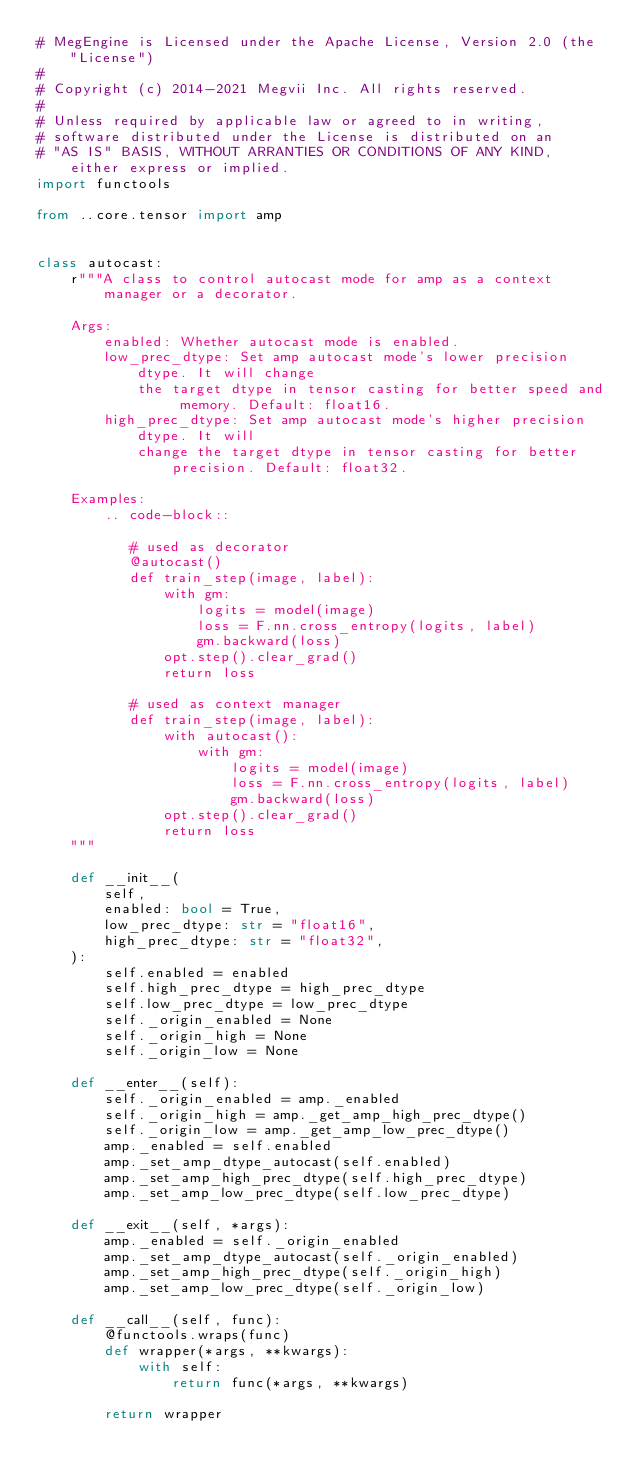<code> <loc_0><loc_0><loc_500><loc_500><_Python_># MegEngine is Licensed under the Apache License, Version 2.0 (the "License")
#
# Copyright (c) 2014-2021 Megvii Inc. All rights reserved.
#
# Unless required by applicable law or agreed to in writing,
# software distributed under the License is distributed on an
# "AS IS" BASIS, WITHOUT ARRANTIES OR CONDITIONS OF ANY KIND, either express or implied.
import functools

from ..core.tensor import amp


class autocast:
    r"""A class to control autocast mode for amp as a context manager or a decorator.

    Args:
        enabled: Whether autocast mode is enabled.
        low_prec_dtype: Set amp autocast mode's lower precision dtype. It will change
            the target dtype in tensor casting for better speed and memory. Default: float16.
        high_prec_dtype: Set amp autocast mode's higher precision dtype. It will
            change the target dtype in tensor casting for better precision. Default: float32.

    Examples:
        .. code-block::

           # used as decorator
           @autocast()
           def train_step(image, label):
               with gm:
                   logits = model(image)
                   loss = F.nn.cross_entropy(logits, label)
                   gm.backward(loss)
               opt.step().clear_grad()
               return loss

           # used as context manager
           def train_step(image, label):
               with autocast():
                   with gm:
                       logits = model(image)
                       loss = F.nn.cross_entropy(logits, label)
                       gm.backward(loss)
               opt.step().clear_grad()
               return loss
    """

    def __init__(
        self,
        enabled: bool = True,
        low_prec_dtype: str = "float16",
        high_prec_dtype: str = "float32",
    ):
        self.enabled = enabled
        self.high_prec_dtype = high_prec_dtype
        self.low_prec_dtype = low_prec_dtype
        self._origin_enabled = None
        self._origin_high = None
        self._origin_low = None

    def __enter__(self):
        self._origin_enabled = amp._enabled
        self._origin_high = amp._get_amp_high_prec_dtype()
        self._origin_low = amp._get_amp_low_prec_dtype()
        amp._enabled = self.enabled
        amp._set_amp_dtype_autocast(self.enabled)
        amp._set_amp_high_prec_dtype(self.high_prec_dtype)
        amp._set_amp_low_prec_dtype(self.low_prec_dtype)

    def __exit__(self, *args):
        amp._enabled = self._origin_enabled
        amp._set_amp_dtype_autocast(self._origin_enabled)
        amp._set_amp_high_prec_dtype(self._origin_high)
        amp._set_amp_low_prec_dtype(self._origin_low)

    def __call__(self, func):
        @functools.wraps(func)
        def wrapper(*args, **kwargs):
            with self:
                return func(*args, **kwargs)

        return wrapper
</code> 